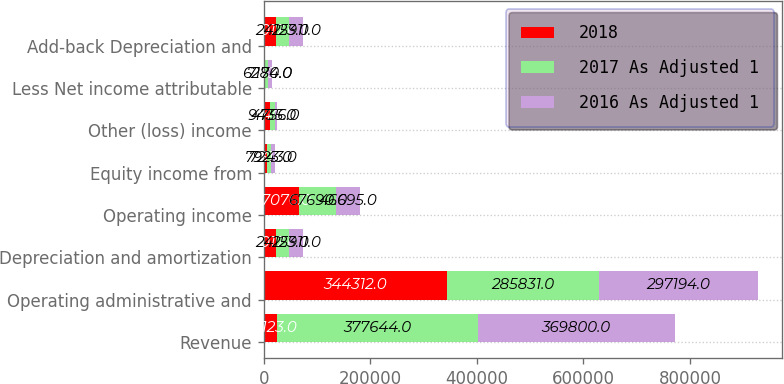<chart> <loc_0><loc_0><loc_500><loc_500><stacked_bar_chart><ecel><fcel>Revenue<fcel>Operating administrative and<fcel>Depreciation and amortization<fcel>Operating income<fcel>Equity income from<fcel>Other (loss) income<fcel>Less Net income attributable<fcel>Add-back Depreciation and<nl><fcel>2018<fcel>24123<fcel>344312<fcel>23017<fcel>67076<fcel>6131<fcel>10840<fcel>2360<fcel>23017<nl><fcel>2017 As Adjusted 1<fcel>377644<fcel>285831<fcel>24123<fcel>67690<fcel>7923<fcel>9435<fcel>6280<fcel>24123<nl><fcel>2016 As Adjusted 1<fcel>369800<fcel>297194<fcel>25911<fcel>46695<fcel>7243<fcel>4756<fcel>7174<fcel>25911<nl></chart> 